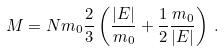Convert formula to latex. <formula><loc_0><loc_0><loc_500><loc_500>M = N m _ { 0 } \frac { 2 } { 3 } \left ( \frac { | E | } { m _ { 0 } } + \frac { 1 } { 2 } \frac { m _ { 0 } } { | E | } \right ) \, .</formula> 